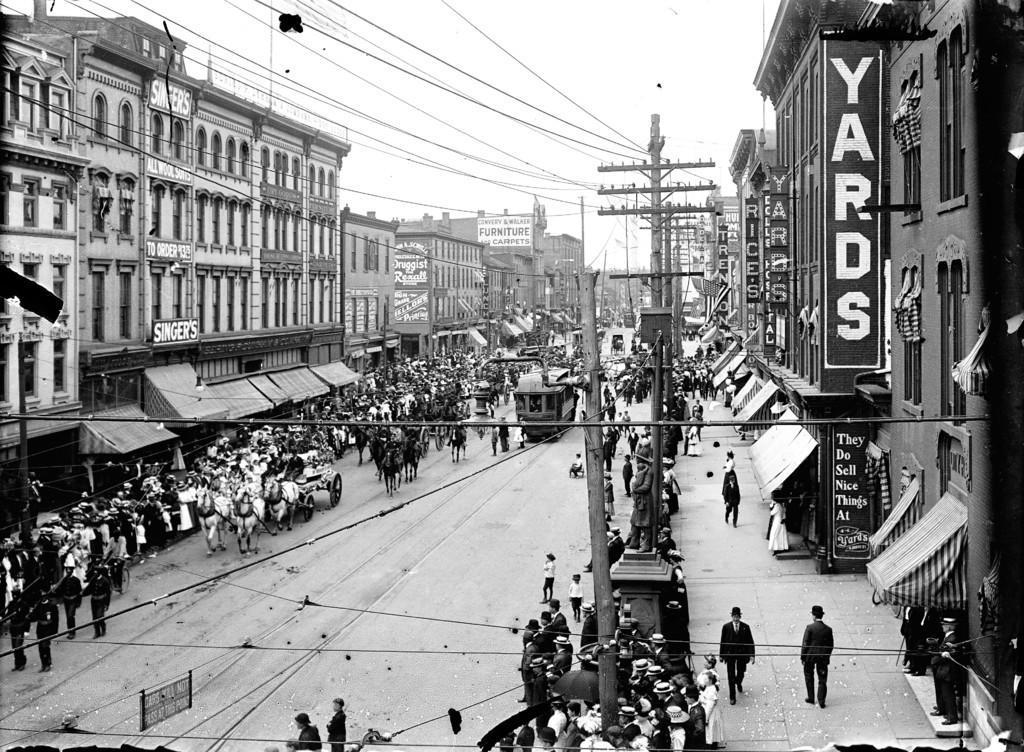In one or two sentences, can you explain what this image depicts? In this image I can see a crowd, light poles, horse carts and vehicles on the road. In the background I can see buildings, wires, boards and the sky. This image is taken may be on the road. 